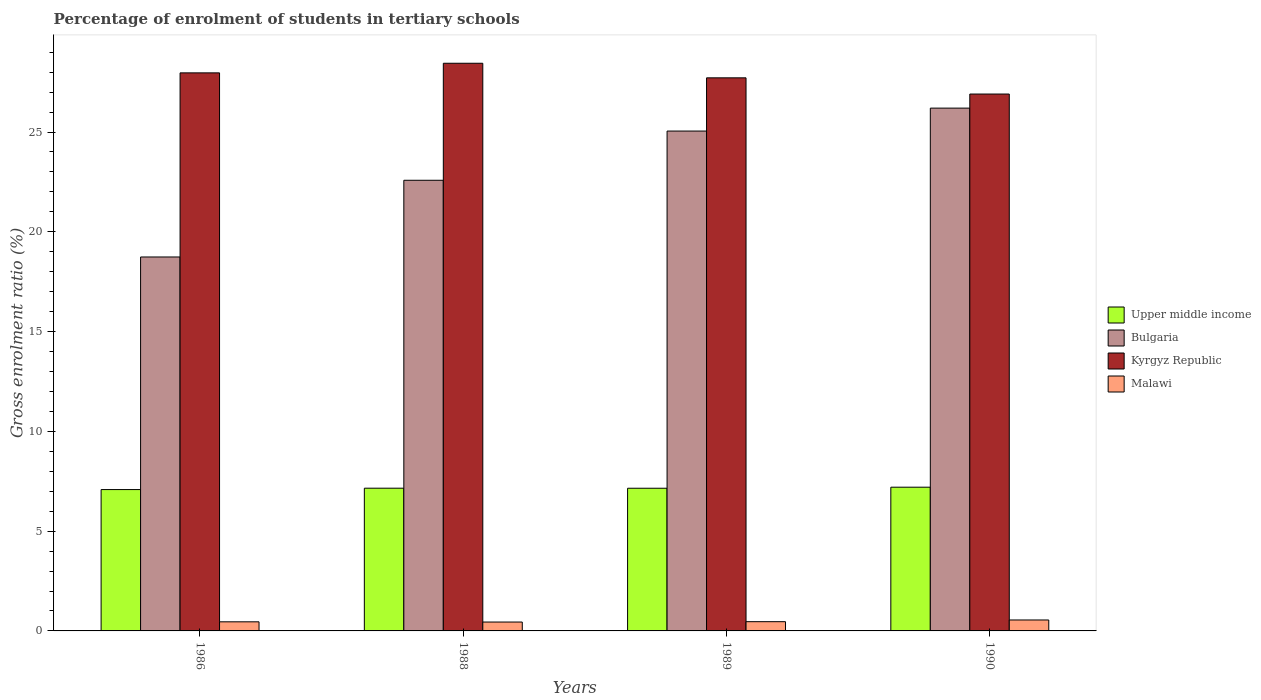How many different coloured bars are there?
Provide a succinct answer. 4. Are the number of bars on each tick of the X-axis equal?
Offer a terse response. Yes. How many bars are there on the 2nd tick from the left?
Ensure brevity in your answer.  4. What is the percentage of students enrolled in tertiary schools in Bulgaria in 1988?
Offer a terse response. 22.58. Across all years, what is the maximum percentage of students enrolled in tertiary schools in Upper middle income?
Your response must be concise. 7.2. Across all years, what is the minimum percentage of students enrolled in tertiary schools in Malawi?
Give a very brief answer. 0.44. What is the total percentage of students enrolled in tertiary schools in Kyrgyz Republic in the graph?
Provide a succinct answer. 111.03. What is the difference between the percentage of students enrolled in tertiary schools in Malawi in 1988 and that in 1990?
Make the answer very short. -0.1. What is the difference between the percentage of students enrolled in tertiary schools in Bulgaria in 1986 and the percentage of students enrolled in tertiary schools in Kyrgyz Republic in 1989?
Provide a short and direct response. -8.98. What is the average percentage of students enrolled in tertiary schools in Kyrgyz Republic per year?
Provide a short and direct response. 27.76. In the year 1988, what is the difference between the percentage of students enrolled in tertiary schools in Malawi and percentage of students enrolled in tertiary schools in Upper middle income?
Offer a terse response. -6.71. In how many years, is the percentage of students enrolled in tertiary schools in Malawi greater than 6 %?
Provide a succinct answer. 0. What is the ratio of the percentage of students enrolled in tertiary schools in Malawi in 1989 to that in 1990?
Your answer should be compact. 0.84. Is the percentage of students enrolled in tertiary schools in Bulgaria in 1988 less than that in 1990?
Your answer should be compact. Yes. What is the difference between the highest and the second highest percentage of students enrolled in tertiary schools in Upper middle income?
Your answer should be compact. 0.05. What is the difference between the highest and the lowest percentage of students enrolled in tertiary schools in Upper middle income?
Offer a very short reply. 0.12. In how many years, is the percentage of students enrolled in tertiary schools in Bulgaria greater than the average percentage of students enrolled in tertiary schools in Bulgaria taken over all years?
Offer a terse response. 2. What does the 1st bar from the left in 1988 represents?
Offer a terse response. Upper middle income. What does the 2nd bar from the right in 1989 represents?
Provide a short and direct response. Kyrgyz Republic. How many bars are there?
Your answer should be compact. 16. How many years are there in the graph?
Offer a terse response. 4. What is the difference between two consecutive major ticks on the Y-axis?
Provide a short and direct response. 5. Are the values on the major ticks of Y-axis written in scientific E-notation?
Keep it short and to the point. No. How are the legend labels stacked?
Provide a succinct answer. Vertical. What is the title of the graph?
Give a very brief answer. Percentage of enrolment of students in tertiary schools. Does "Saudi Arabia" appear as one of the legend labels in the graph?
Ensure brevity in your answer.  No. What is the Gross enrolment ratio (%) in Upper middle income in 1986?
Keep it short and to the point. 7.08. What is the Gross enrolment ratio (%) in Bulgaria in 1986?
Keep it short and to the point. 18.74. What is the Gross enrolment ratio (%) of Kyrgyz Republic in 1986?
Ensure brevity in your answer.  27.96. What is the Gross enrolment ratio (%) in Malawi in 1986?
Offer a terse response. 0.46. What is the Gross enrolment ratio (%) of Upper middle income in 1988?
Offer a very short reply. 7.15. What is the Gross enrolment ratio (%) in Bulgaria in 1988?
Ensure brevity in your answer.  22.58. What is the Gross enrolment ratio (%) of Kyrgyz Republic in 1988?
Offer a terse response. 28.45. What is the Gross enrolment ratio (%) in Malawi in 1988?
Offer a terse response. 0.44. What is the Gross enrolment ratio (%) of Upper middle income in 1989?
Keep it short and to the point. 7.15. What is the Gross enrolment ratio (%) of Bulgaria in 1989?
Your response must be concise. 25.05. What is the Gross enrolment ratio (%) in Kyrgyz Republic in 1989?
Offer a terse response. 27.72. What is the Gross enrolment ratio (%) of Malawi in 1989?
Make the answer very short. 0.46. What is the Gross enrolment ratio (%) of Upper middle income in 1990?
Offer a terse response. 7.2. What is the Gross enrolment ratio (%) in Bulgaria in 1990?
Ensure brevity in your answer.  26.2. What is the Gross enrolment ratio (%) of Kyrgyz Republic in 1990?
Ensure brevity in your answer.  26.9. What is the Gross enrolment ratio (%) in Malawi in 1990?
Your answer should be compact. 0.55. Across all years, what is the maximum Gross enrolment ratio (%) of Upper middle income?
Ensure brevity in your answer.  7.2. Across all years, what is the maximum Gross enrolment ratio (%) in Bulgaria?
Make the answer very short. 26.2. Across all years, what is the maximum Gross enrolment ratio (%) of Kyrgyz Republic?
Provide a short and direct response. 28.45. Across all years, what is the maximum Gross enrolment ratio (%) of Malawi?
Give a very brief answer. 0.55. Across all years, what is the minimum Gross enrolment ratio (%) in Upper middle income?
Keep it short and to the point. 7.08. Across all years, what is the minimum Gross enrolment ratio (%) in Bulgaria?
Your answer should be compact. 18.74. Across all years, what is the minimum Gross enrolment ratio (%) in Kyrgyz Republic?
Your answer should be compact. 26.9. Across all years, what is the minimum Gross enrolment ratio (%) of Malawi?
Ensure brevity in your answer.  0.44. What is the total Gross enrolment ratio (%) in Upper middle income in the graph?
Give a very brief answer. 28.59. What is the total Gross enrolment ratio (%) of Bulgaria in the graph?
Provide a short and direct response. 92.57. What is the total Gross enrolment ratio (%) of Kyrgyz Republic in the graph?
Offer a very short reply. 111.03. What is the total Gross enrolment ratio (%) of Malawi in the graph?
Your answer should be very brief. 1.91. What is the difference between the Gross enrolment ratio (%) in Upper middle income in 1986 and that in 1988?
Offer a very short reply. -0.07. What is the difference between the Gross enrolment ratio (%) of Bulgaria in 1986 and that in 1988?
Offer a terse response. -3.84. What is the difference between the Gross enrolment ratio (%) of Kyrgyz Republic in 1986 and that in 1988?
Provide a short and direct response. -0.48. What is the difference between the Gross enrolment ratio (%) in Malawi in 1986 and that in 1988?
Your response must be concise. 0.01. What is the difference between the Gross enrolment ratio (%) in Upper middle income in 1986 and that in 1989?
Make the answer very short. -0.07. What is the difference between the Gross enrolment ratio (%) of Bulgaria in 1986 and that in 1989?
Offer a terse response. -6.31. What is the difference between the Gross enrolment ratio (%) in Kyrgyz Republic in 1986 and that in 1989?
Your response must be concise. 0.25. What is the difference between the Gross enrolment ratio (%) in Malawi in 1986 and that in 1989?
Provide a succinct answer. -0.01. What is the difference between the Gross enrolment ratio (%) of Upper middle income in 1986 and that in 1990?
Your answer should be compact. -0.12. What is the difference between the Gross enrolment ratio (%) in Bulgaria in 1986 and that in 1990?
Your response must be concise. -7.46. What is the difference between the Gross enrolment ratio (%) in Kyrgyz Republic in 1986 and that in 1990?
Provide a short and direct response. 1.06. What is the difference between the Gross enrolment ratio (%) of Malawi in 1986 and that in 1990?
Your answer should be very brief. -0.09. What is the difference between the Gross enrolment ratio (%) of Upper middle income in 1988 and that in 1989?
Offer a very short reply. 0. What is the difference between the Gross enrolment ratio (%) of Bulgaria in 1988 and that in 1989?
Make the answer very short. -2.47. What is the difference between the Gross enrolment ratio (%) in Kyrgyz Republic in 1988 and that in 1989?
Offer a very short reply. 0.73. What is the difference between the Gross enrolment ratio (%) in Malawi in 1988 and that in 1989?
Your response must be concise. -0.02. What is the difference between the Gross enrolment ratio (%) in Upper middle income in 1988 and that in 1990?
Offer a very short reply. -0.05. What is the difference between the Gross enrolment ratio (%) in Bulgaria in 1988 and that in 1990?
Offer a terse response. -3.62. What is the difference between the Gross enrolment ratio (%) in Kyrgyz Republic in 1988 and that in 1990?
Offer a terse response. 1.54. What is the difference between the Gross enrolment ratio (%) in Malawi in 1988 and that in 1990?
Your response must be concise. -0.1. What is the difference between the Gross enrolment ratio (%) of Upper middle income in 1989 and that in 1990?
Give a very brief answer. -0.05. What is the difference between the Gross enrolment ratio (%) of Bulgaria in 1989 and that in 1990?
Provide a short and direct response. -1.15. What is the difference between the Gross enrolment ratio (%) in Kyrgyz Republic in 1989 and that in 1990?
Your response must be concise. 0.81. What is the difference between the Gross enrolment ratio (%) of Malawi in 1989 and that in 1990?
Offer a terse response. -0.09. What is the difference between the Gross enrolment ratio (%) of Upper middle income in 1986 and the Gross enrolment ratio (%) of Bulgaria in 1988?
Ensure brevity in your answer.  -15.5. What is the difference between the Gross enrolment ratio (%) in Upper middle income in 1986 and the Gross enrolment ratio (%) in Kyrgyz Republic in 1988?
Ensure brevity in your answer.  -21.36. What is the difference between the Gross enrolment ratio (%) in Upper middle income in 1986 and the Gross enrolment ratio (%) in Malawi in 1988?
Your answer should be very brief. 6.64. What is the difference between the Gross enrolment ratio (%) in Bulgaria in 1986 and the Gross enrolment ratio (%) in Kyrgyz Republic in 1988?
Give a very brief answer. -9.71. What is the difference between the Gross enrolment ratio (%) in Bulgaria in 1986 and the Gross enrolment ratio (%) in Malawi in 1988?
Provide a short and direct response. 18.29. What is the difference between the Gross enrolment ratio (%) in Kyrgyz Republic in 1986 and the Gross enrolment ratio (%) in Malawi in 1988?
Offer a very short reply. 27.52. What is the difference between the Gross enrolment ratio (%) of Upper middle income in 1986 and the Gross enrolment ratio (%) of Bulgaria in 1989?
Give a very brief answer. -17.97. What is the difference between the Gross enrolment ratio (%) of Upper middle income in 1986 and the Gross enrolment ratio (%) of Kyrgyz Republic in 1989?
Your answer should be compact. -20.63. What is the difference between the Gross enrolment ratio (%) in Upper middle income in 1986 and the Gross enrolment ratio (%) in Malawi in 1989?
Ensure brevity in your answer.  6.62. What is the difference between the Gross enrolment ratio (%) in Bulgaria in 1986 and the Gross enrolment ratio (%) in Kyrgyz Republic in 1989?
Offer a very short reply. -8.98. What is the difference between the Gross enrolment ratio (%) of Bulgaria in 1986 and the Gross enrolment ratio (%) of Malawi in 1989?
Give a very brief answer. 18.28. What is the difference between the Gross enrolment ratio (%) of Kyrgyz Republic in 1986 and the Gross enrolment ratio (%) of Malawi in 1989?
Your answer should be very brief. 27.5. What is the difference between the Gross enrolment ratio (%) in Upper middle income in 1986 and the Gross enrolment ratio (%) in Bulgaria in 1990?
Your answer should be very brief. -19.11. What is the difference between the Gross enrolment ratio (%) of Upper middle income in 1986 and the Gross enrolment ratio (%) of Kyrgyz Republic in 1990?
Make the answer very short. -19.82. What is the difference between the Gross enrolment ratio (%) in Upper middle income in 1986 and the Gross enrolment ratio (%) in Malawi in 1990?
Your answer should be compact. 6.54. What is the difference between the Gross enrolment ratio (%) of Bulgaria in 1986 and the Gross enrolment ratio (%) of Kyrgyz Republic in 1990?
Ensure brevity in your answer.  -8.16. What is the difference between the Gross enrolment ratio (%) of Bulgaria in 1986 and the Gross enrolment ratio (%) of Malawi in 1990?
Keep it short and to the point. 18.19. What is the difference between the Gross enrolment ratio (%) in Kyrgyz Republic in 1986 and the Gross enrolment ratio (%) in Malawi in 1990?
Ensure brevity in your answer.  27.42. What is the difference between the Gross enrolment ratio (%) of Upper middle income in 1988 and the Gross enrolment ratio (%) of Bulgaria in 1989?
Provide a short and direct response. -17.9. What is the difference between the Gross enrolment ratio (%) of Upper middle income in 1988 and the Gross enrolment ratio (%) of Kyrgyz Republic in 1989?
Provide a succinct answer. -20.56. What is the difference between the Gross enrolment ratio (%) in Upper middle income in 1988 and the Gross enrolment ratio (%) in Malawi in 1989?
Your answer should be very brief. 6.69. What is the difference between the Gross enrolment ratio (%) in Bulgaria in 1988 and the Gross enrolment ratio (%) in Kyrgyz Republic in 1989?
Offer a terse response. -5.13. What is the difference between the Gross enrolment ratio (%) of Bulgaria in 1988 and the Gross enrolment ratio (%) of Malawi in 1989?
Offer a terse response. 22.12. What is the difference between the Gross enrolment ratio (%) of Kyrgyz Republic in 1988 and the Gross enrolment ratio (%) of Malawi in 1989?
Give a very brief answer. 27.98. What is the difference between the Gross enrolment ratio (%) of Upper middle income in 1988 and the Gross enrolment ratio (%) of Bulgaria in 1990?
Make the answer very short. -19.05. What is the difference between the Gross enrolment ratio (%) of Upper middle income in 1988 and the Gross enrolment ratio (%) of Kyrgyz Republic in 1990?
Offer a very short reply. -19.75. What is the difference between the Gross enrolment ratio (%) in Upper middle income in 1988 and the Gross enrolment ratio (%) in Malawi in 1990?
Your answer should be compact. 6.6. What is the difference between the Gross enrolment ratio (%) of Bulgaria in 1988 and the Gross enrolment ratio (%) of Kyrgyz Republic in 1990?
Your answer should be very brief. -4.32. What is the difference between the Gross enrolment ratio (%) in Bulgaria in 1988 and the Gross enrolment ratio (%) in Malawi in 1990?
Make the answer very short. 22.03. What is the difference between the Gross enrolment ratio (%) of Kyrgyz Republic in 1988 and the Gross enrolment ratio (%) of Malawi in 1990?
Ensure brevity in your answer.  27.9. What is the difference between the Gross enrolment ratio (%) of Upper middle income in 1989 and the Gross enrolment ratio (%) of Bulgaria in 1990?
Ensure brevity in your answer.  -19.05. What is the difference between the Gross enrolment ratio (%) in Upper middle income in 1989 and the Gross enrolment ratio (%) in Kyrgyz Republic in 1990?
Offer a terse response. -19.75. What is the difference between the Gross enrolment ratio (%) in Upper middle income in 1989 and the Gross enrolment ratio (%) in Malawi in 1990?
Give a very brief answer. 6.6. What is the difference between the Gross enrolment ratio (%) of Bulgaria in 1989 and the Gross enrolment ratio (%) of Kyrgyz Republic in 1990?
Keep it short and to the point. -1.85. What is the difference between the Gross enrolment ratio (%) in Bulgaria in 1989 and the Gross enrolment ratio (%) in Malawi in 1990?
Provide a succinct answer. 24.5. What is the difference between the Gross enrolment ratio (%) of Kyrgyz Republic in 1989 and the Gross enrolment ratio (%) of Malawi in 1990?
Your answer should be very brief. 27.17. What is the average Gross enrolment ratio (%) of Upper middle income per year?
Offer a very short reply. 7.15. What is the average Gross enrolment ratio (%) of Bulgaria per year?
Your response must be concise. 23.14. What is the average Gross enrolment ratio (%) in Kyrgyz Republic per year?
Offer a very short reply. 27.76. What is the average Gross enrolment ratio (%) in Malawi per year?
Provide a short and direct response. 0.48. In the year 1986, what is the difference between the Gross enrolment ratio (%) of Upper middle income and Gross enrolment ratio (%) of Bulgaria?
Keep it short and to the point. -11.65. In the year 1986, what is the difference between the Gross enrolment ratio (%) of Upper middle income and Gross enrolment ratio (%) of Kyrgyz Republic?
Provide a short and direct response. -20.88. In the year 1986, what is the difference between the Gross enrolment ratio (%) of Upper middle income and Gross enrolment ratio (%) of Malawi?
Make the answer very short. 6.63. In the year 1986, what is the difference between the Gross enrolment ratio (%) of Bulgaria and Gross enrolment ratio (%) of Kyrgyz Republic?
Ensure brevity in your answer.  -9.23. In the year 1986, what is the difference between the Gross enrolment ratio (%) in Bulgaria and Gross enrolment ratio (%) in Malawi?
Your answer should be very brief. 18.28. In the year 1986, what is the difference between the Gross enrolment ratio (%) in Kyrgyz Republic and Gross enrolment ratio (%) in Malawi?
Keep it short and to the point. 27.51. In the year 1988, what is the difference between the Gross enrolment ratio (%) of Upper middle income and Gross enrolment ratio (%) of Bulgaria?
Provide a succinct answer. -15.43. In the year 1988, what is the difference between the Gross enrolment ratio (%) in Upper middle income and Gross enrolment ratio (%) in Kyrgyz Republic?
Offer a very short reply. -21.29. In the year 1988, what is the difference between the Gross enrolment ratio (%) of Upper middle income and Gross enrolment ratio (%) of Malawi?
Provide a succinct answer. 6.71. In the year 1988, what is the difference between the Gross enrolment ratio (%) of Bulgaria and Gross enrolment ratio (%) of Kyrgyz Republic?
Provide a short and direct response. -5.86. In the year 1988, what is the difference between the Gross enrolment ratio (%) in Bulgaria and Gross enrolment ratio (%) in Malawi?
Your response must be concise. 22.14. In the year 1988, what is the difference between the Gross enrolment ratio (%) of Kyrgyz Republic and Gross enrolment ratio (%) of Malawi?
Your answer should be compact. 28. In the year 1989, what is the difference between the Gross enrolment ratio (%) in Upper middle income and Gross enrolment ratio (%) in Bulgaria?
Provide a succinct answer. -17.9. In the year 1989, what is the difference between the Gross enrolment ratio (%) in Upper middle income and Gross enrolment ratio (%) in Kyrgyz Republic?
Offer a very short reply. -20.57. In the year 1989, what is the difference between the Gross enrolment ratio (%) in Upper middle income and Gross enrolment ratio (%) in Malawi?
Keep it short and to the point. 6.69. In the year 1989, what is the difference between the Gross enrolment ratio (%) in Bulgaria and Gross enrolment ratio (%) in Kyrgyz Republic?
Offer a very short reply. -2.67. In the year 1989, what is the difference between the Gross enrolment ratio (%) of Bulgaria and Gross enrolment ratio (%) of Malawi?
Offer a very short reply. 24.59. In the year 1989, what is the difference between the Gross enrolment ratio (%) of Kyrgyz Republic and Gross enrolment ratio (%) of Malawi?
Give a very brief answer. 27.25. In the year 1990, what is the difference between the Gross enrolment ratio (%) of Upper middle income and Gross enrolment ratio (%) of Bulgaria?
Your answer should be compact. -19. In the year 1990, what is the difference between the Gross enrolment ratio (%) of Upper middle income and Gross enrolment ratio (%) of Kyrgyz Republic?
Your answer should be very brief. -19.7. In the year 1990, what is the difference between the Gross enrolment ratio (%) of Upper middle income and Gross enrolment ratio (%) of Malawi?
Provide a short and direct response. 6.65. In the year 1990, what is the difference between the Gross enrolment ratio (%) of Bulgaria and Gross enrolment ratio (%) of Kyrgyz Republic?
Give a very brief answer. -0.71. In the year 1990, what is the difference between the Gross enrolment ratio (%) in Bulgaria and Gross enrolment ratio (%) in Malawi?
Give a very brief answer. 25.65. In the year 1990, what is the difference between the Gross enrolment ratio (%) in Kyrgyz Republic and Gross enrolment ratio (%) in Malawi?
Ensure brevity in your answer.  26.35. What is the ratio of the Gross enrolment ratio (%) of Upper middle income in 1986 to that in 1988?
Your answer should be very brief. 0.99. What is the ratio of the Gross enrolment ratio (%) in Bulgaria in 1986 to that in 1988?
Offer a terse response. 0.83. What is the ratio of the Gross enrolment ratio (%) of Kyrgyz Republic in 1986 to that in 1988?
Offer a terse response. 0.98. What is the ratio of the Gross enrolment ratio (%) of Malawi in 1986 to that in 1988?
Ensure brevity in your answer.  1.02. What is the ratio of the Gross enrolment ratio (%) of Bulgaria in 1986 to that in 1989?
Offer a terse response. 0.75. What is the ratio of the Gross enrolment ratio (%) in Kyrgyz Republic in 1986 to that in 1989?
Keep it short and to the point. 1.01. What is the ratio of the Gross enrolment ratio (%) in Upper middle income in 1986 to that in 1990?
Make the answer very short. 0.98. What is the ratio of the Gross enrolment ratio (%) in Bulgaria in 1986 to that in 1990?
Your answer should be compact. 0.72. What is the ratio of the Gross enrolment ratio (%) of Kyrgyz Republic in 1986 to that in 1990?
Provide a succinct answer. 1.04. What is the ratio of the Gross enrolment ratio (%) of Malawi in 1986 to that in 1990?
Your response must be concise. 0.83. What is the ratio of the Gross enrolment ratio (%) of Upper middle income in 1988 to that in 1989?
Provide a short and direct response. 1. What is the ratio of the Gross enrolment ratio (%) of Bulgaria in 1988 to that in 1989?
Ensure brevity in your answer.  0.9. What is the ratio of the Gross enrolment ratio (%) in Kyrgyz Republic in 1988 to that in 1989?
Make the answer very short. 1.03. What is the ratio of the Gross enrolment ratio (%) in Malawi in 1988 to that in 1989?
Give a very brief answer. 0.96. What is the ratio of the Gross enrolment ratio (%) in Bulgaria in 1988 to that in 1990?
Offer a very short reply. 0.86. What is the ratio of the Gross enrolment ratio (%) of Kyrgyz Republic in 1988 to that in 1990?
Ensure brevity in your answer.  1.06. What is the ratio of the Gross enrolment ratio (%) of Malawi in 1988 to that in 1990?
Offer a terse response. 0.81. What is the ratio of the Gross enrolment ratio (%) in Bulgaria in 1989 to that in 1990?
Make the answer very short. 0.96. What is the ratio of the Gross enrolment ratio (%) in Kyrgyz Republic in 1989 to that in 1990?
Make the answer very short. 1.03. What is the ratio of the Gross enrolment ratio (%) of Malawi in 1989 to that in 1990?
Make the answer very short. 0.84. What is the difference between the highest and the second highest Gross enrolment ratio (%) of Upper middle income?
Keep it short and to the point. 0.05. What is the difference between the highest and the second highest Gross enrolment ratio (%) of Bulgaria?
Keep it short and to the point. 1.15. What is the difference between the highest and the second highest Gross enrolment ratio (%) of Kyrgyz Republic?
Your response must be concise. 0.48. What is the difference between the highest and the second highest Gross enrolment ratio (%) in Malawi?
Offer a very short reply. 0.09. What is the difference between the highest and the lowest Gross enrolment ratio (%) of Upper middle income?
Make the answer very short. 0.12. What is the difference between the highest and the lowest Gross enrolment ratio (%) in Bulgaria?
Give a very brief answer. 7.46. What is the difference between the highest and the lowest Gross enrolment ratio (%) in Kyrgyz Republic?
Provide a short and direct response. 1.54. What is the difference between the highest and the lowest Gross enrolment ratio (%) of Malawi?
Offer a very short reply. 0.1. 